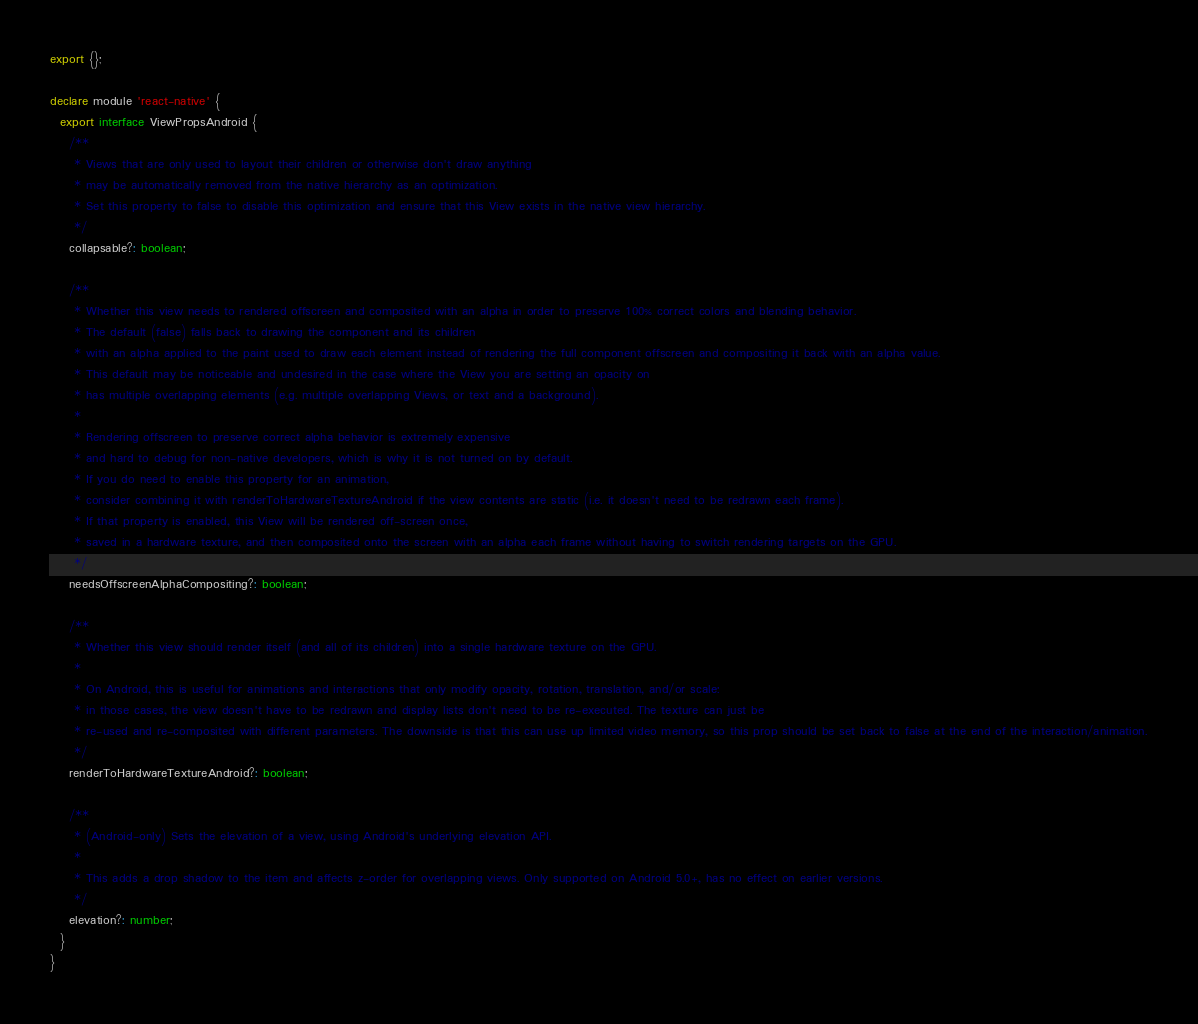<code> <loc_0><loc_0><loc_500><loc_500><_TypeScript_>export {};

declare module 'react-native' {
  export interface ViewPropsAndroid {
    /**
     * Views that are only used to layout their children or otherwise don't draw anything
     * may be automatically removed from the native hierarchy as an optimization.
     * Set this property to false to disable this optimization and ensure that this View exists in the native view hierarchy.
     */
    collapsable?: boolean;

    /**
     * Whether this view needs to rendered offscreen and composited with an alpha in order to preserve 100% correct colors and blending behavior.
     * The default (false) falls back to drawing the component and its children
     * with an alpha applied to the paint used to draw each element instead of rendering the full component offscreen and compositing it back with an alpha value.
     * This default may be noticeable and undesired in the case where the View you are setting an opacity on
     * has multiple overlapping elements (e.g. multiple overlapping Views, or text and a background).
     *
     * Rendering offscreen to preserve correct alpha behavior is extremely expensive
     * and hard to debug for non-native developers, which is why it is not turned on by default.
     * If you do need to enable this property for an animation,
     * consider combining it with renderToHardwareTextureAndroid if the view contents are static (i.e. it doesn't need to be redrawn each frame).
     * If that property is enabled, this View will be rendered off-screen once,
     * saved in a hardware texture, and then composited onto the screen with an alpha each frame without having to switch rendering targets on the GPU.
     */
    needsOffscreenAlphaCompositing?: boolean;

    /**
     * Whether this view should render itself (and all of its children) into a single hardware texture on the GPU.
     *
     * On Android, this is useful for animations and interactions that only modify opacity, rotation, translation, and/or scale:
     * in those cases, the view doesn't have to be redrawn and display lists don't need to be re-executed. The texture can just be
     * re-used and re-composited with different parameters. The downside is that this can use up limited video memory, so this prop should be set back to false at the end of the interaction/animation.
     */
    renderToHardwareTextureAndroid?: boolean;

    /**
     * (Android-only) Sets the elevation of a view, using Android's underlying elevation API.
     *
     * This adds a drop shadow to the item and affects z-order for overlapping views. Only supported on Android 5.0+, has no effect on earlier versions.
     */
    elevation?: number;
  }
}
</code> 